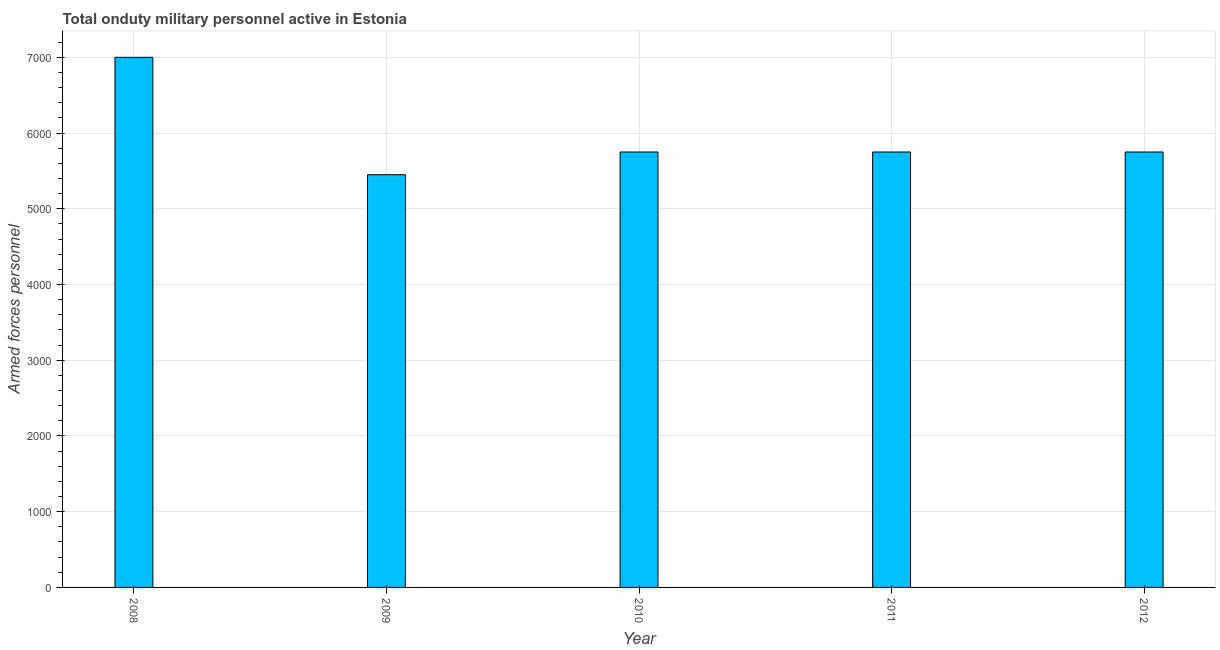Does the graph contain grids?
Your answer should be very brief. Yes. What is the title of the graph?
Provide a short and direct response. Total onduty military personnel active in Estonia. What is the label or title of the Y-axis?
Offer a terse response. Armed forces personnel. What is the number of armed forces personnel in 2011?
Provide a succinct answer. 5750. Across all years, what is the maximum number of armed forces personnel?
Keep it short and to the point. 7000. Across all years, what is the minimum number of armed forces personnel?
Provide a succinct answer. 5450. In which year was the number of armed forces personnel minimum?
Your answer should be compact. 2009. What is the sum of the number of armed forces personnel?
Give a very brief answer. 2.97e+04. What is the difference between the number of armed forces personnel in 2010 and 2012?
Your answer should be compact. 0. What is the average number of armed forces personnel per year?
Give a very brief answer. 5940. What is the median number of armed forces personnel?
Offer a very short reply. 5750. In how many years, is the number of armed forces personnel greater than 6200 ?
Keep it short and to the point. 1. Do a majority of the years between 2010 and 2012 (inclusive) have number of armed forces personnel greater than 5200 ?
Your response must be concise. Yes. What is the ratio of the number of armed forces personnel in 2008 to that in 2011?
Keep it short and to the point. 1.22. Is the number of armed forces personnel in 2008 less than that in 2011?
Keep it short and to the point. No. What is the difference between the highest and the second highest number of armed forces personnel?
Ensure brevity in your answer.  1250. Is the sum of the number of armed forces personnel in 2010 and 2012 greater than the maximum number of armed forces personnel across all years?
Provide a short and direct response. Yes. What is the difference between the highest and the lowest number of armed forces personnel?
Provide a succinct answer. 1550. In how many years, is the number of armed forces personnel greater than the average number of armed forces personnel taken over all years?
Offer a very short reply. 1. How many bars are there?
Ensure brevity in your answer.  5. What is the difference between two consecutive major ticks on the Y-axis?
Provide a succinct answer. 1000. What is the Armed forces personnel in 2008?
Ensure brevity in your answer.  7000. What is the Armed forces personnel of 2009?
Provide a short and direct response. 5450. What is the Armed forces personnel of 2010?
Keep it short and to the point. 5750. What is the Armed forces personnel in 2011?
Offer a terse response. 5750. What is the Armed forces personnel of 2012?
Offer a very short reply. 5750. What is the difference between the Armed forces personnel in 2008 and 2009?
Keep it short and to the point. 1550. What is the difference between the Armed forces personnel in 2008 and 2010?
Offer a terse response. 1250. What is the difference between the Armed forces personnel in 2008 and 2011?
Your answer should be compact. 1250. What is the difference between the Armed forces personnel in 2008 and 2012?
Keep it short and to the point. 1250. What is the difference between the Armed forces personnel in 2009 and 2010?
Make the answer very short. -300. What is the difference between the Armed forces personnel in 2009 and 2011?
Your answer should be compact. -300. What is the difference between the Armed forces personnel in 2009 and 2012?
Offer a terse response. -300. What is the difference between the Armed forces personnel in 2010 and 2011?
Make the answer very short. 0. What is the difference between the Armed forces personnel in 2010 and 2012?
Your answer should be compact. 0. What is the ratio of the Armed forces personnel in 2008 to that in 2009?
Your response must be concise. 1.28. What is the ratio of the Armed forces personnel in 2008 to that in 2010?
Your answer should be compact. 1.22. What is the ratio of the Armed forces personnel in 2008 to that in 2011?
Your answer should be compact. 1.22. What is the ratio of the Armed forces personnel in 2008 to that in 2012?
Provide a short and direct response. 1.22. What is the ratio of the Armed forces personnel in 2009 to that in 2010?
Make the answer very short. 0.95. What is the ratio of the Armed forces personnel in 2009 to that in 2011?
Your answer should be compact. 0.95. What is the ratio of the Armed forces personnel in 2009 to that in 2012?
Make the answer very short. 0.95. What is the ratio of the Armed forces personnel in 2010 to that in 2011?
Offer a terse response. 1. 